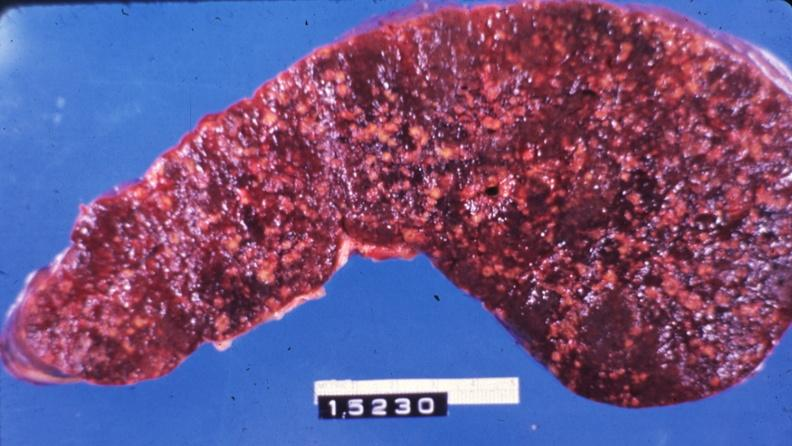where is this part in?
Answer the question using a single word or phrase. Spleen 